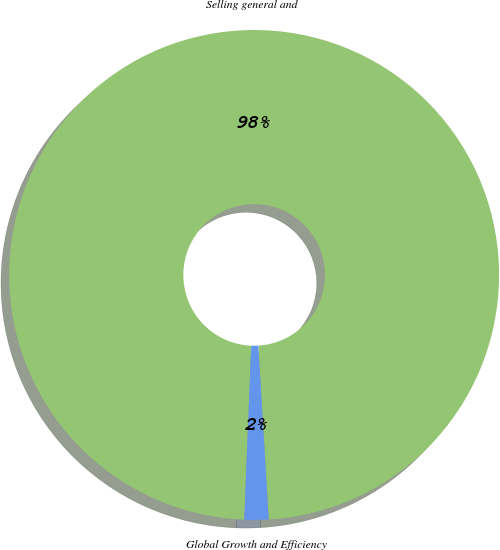Convert chart. <chart><loc_0><loc_0><loc_500><loc_500><pie_chart><fcel>Selling general and<fcel>Global Growth and Efficiency<nl><fcel>98.41%<fcel>1.59%<nl></chart> 